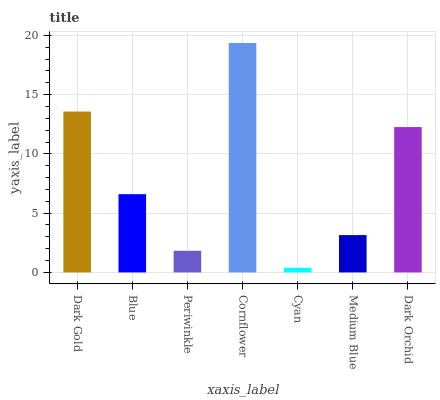Is Cyan the minimum?
Answer yes or no. Yes. Is Cornflower the maximum?
Answer yes or no. Yes. Is Blue the minimum?
Answer yes or no. No. Is Blue the maximum?
Answer yes or no. No. Is Dark Gold greater than Blue?
Answer yes or no. Yes. Is Blue less than Dark Gold?
Answer yes or no. Yes. Is Blue greater than Dark Gold?
Answer yes or no. No. Is Dark Gold less than Blue?
Answer yes or no. No. Is Blue the high median?
Answer yes or no. Yes. Is Blue the low median?
Answer yes or no. Yes. Is Cornflower the high median?
Answer yes or no. No. Is Periwinkle the low median?
Answer yes or no. No. 